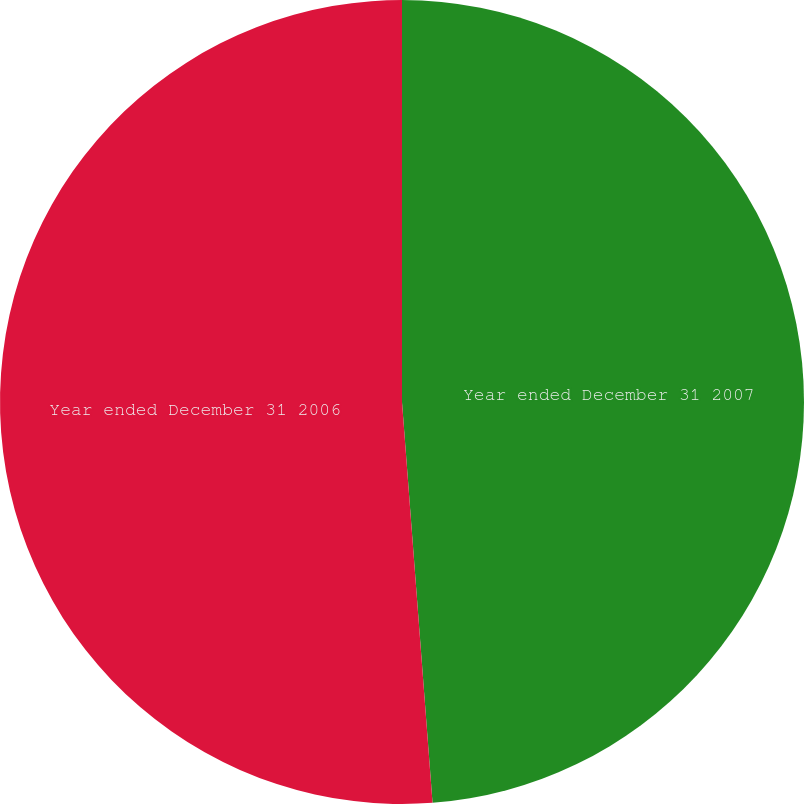Convert chart. <chart><loc_0><loc_0><loc_500><loc_500><pie_chart><fcel>Year ended December 31 2007<fcel>Year ended December 31 2006<nl><fcel>48.79%<fcel>51.21%<nl></chart> 